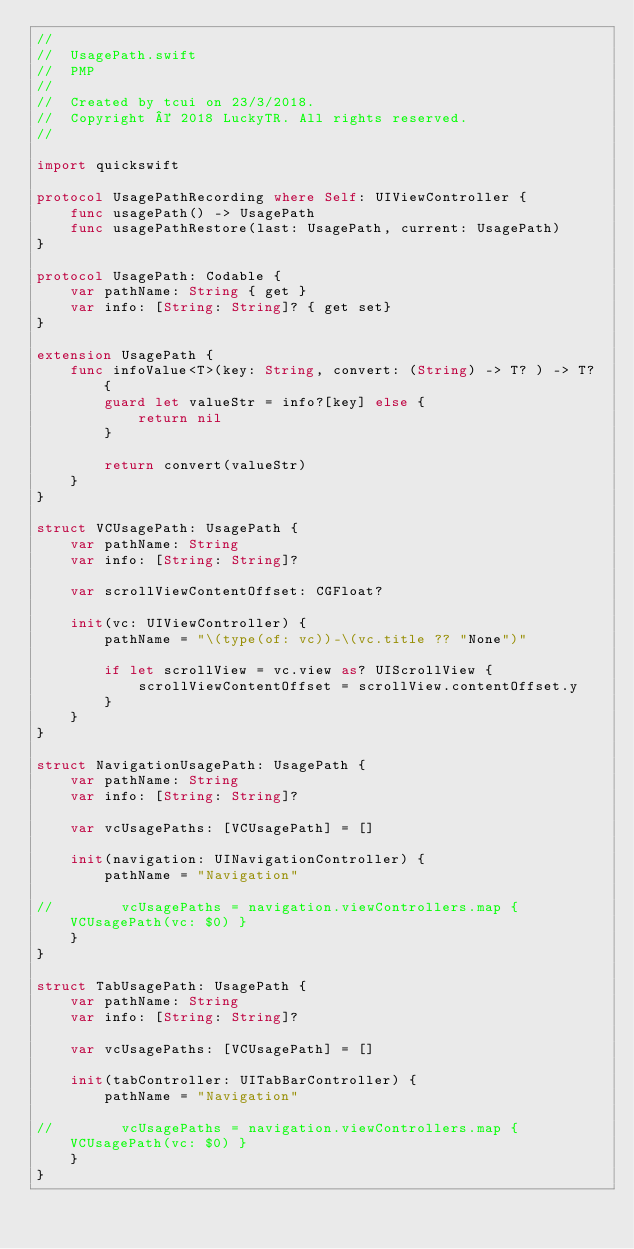<code> <loc_0><loc_0><loc_500><loc_500><_Swift_>//
//  UsagePath.swift
//  PMP
//
//  Created by tcui on 23/3/2018.
//  Copyright © 2018 LuckyTR. All rights reserved.
//

import quickswift

protocol UsagePathRecording where Self: UIViewController {
    func usagePath() -> UsagePath
    func usagePathRestore(last: UsagePath, current: UsagePath)
}

protocol UsagePath: Codable {
    var pathName: String { get }
    var info: [String: String]? { get set}
}

extension UsagePath {
    func infoValue<T>(key: String, convert: (String) -> T? ) -> T? {
        guard let valueStr = info?[key] else {
            return nil
        }

        return convert(valueStr)
    }
}

struct VCUsagePath: UsagePath {
    var pathName: String
    var info: [String: String]?

    var scrollViewContentOffset: CGFloat?

    init(vc: UIViewController) {
        pathName = "\(type(of: vc))-\(vc.title ?? "None")"

        if let scrollView = vc.view as? UIScrollView {
            scrollViewContentOffset = scrollView.contentOffset.y
        }
    }
}

struct NavigationUsagePath: UsagePath {
    var pathName: String
    var info: [String: String]?

    var vcUsagePaths: [VCUsagePath] = []

    init(navigation: UINavigationController) {
        pathName = "Navigation"

//        vcUsagePaths = navigation.viewControllers.map { VCUsagePath(vc: $0) }
    }
}

struct TabUsagePath: UsagePath {
    var pathName: String
    var info: [String: String]?

    var vcUsagePaths: [VCUsagePath] = []

    init(tabController: UITabBarController) {
        pathName = "Navigation"

//        vcUsagePaths = navigation.viewControllers.map { VCUsagePath(vc: $0) }
    }
}
</code> 